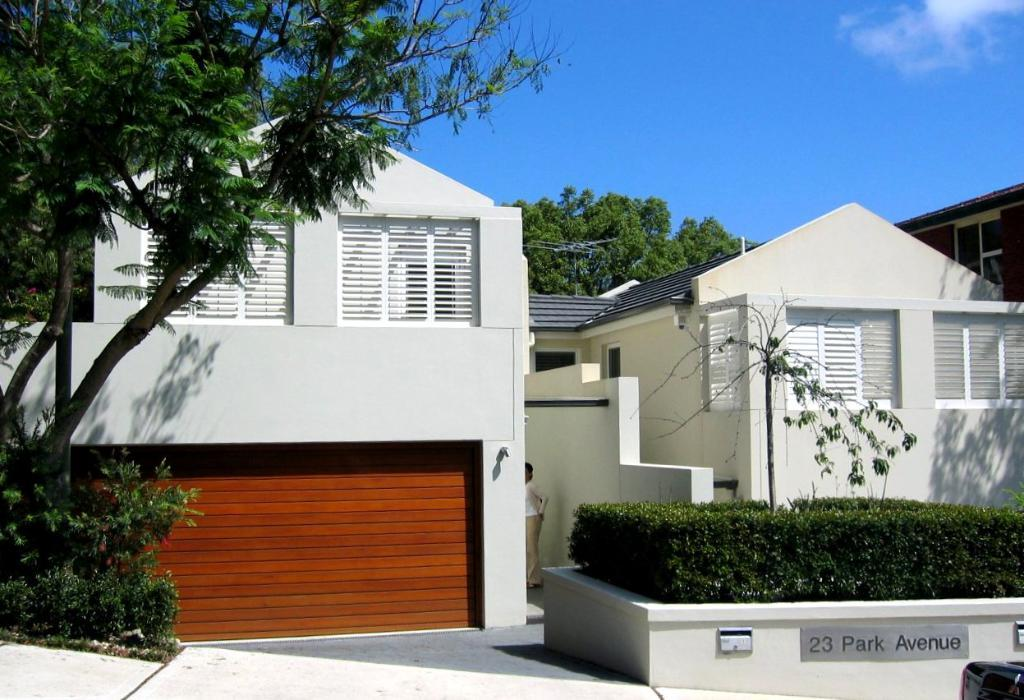What type of structures can be seen in the image? There are buildings in the image. What natural elements are present in the image? There are trees and clouds in the image. What type of vegetation can be seen in the image? There are plants in the image. Who or what is located in the middle of the image? There is a person in the middle of the image. Where are the books located in the image? There are no books present in the image. Can you describe the seat that the person is sitting on in the image? There is no seat present in the image; the person is standing. 